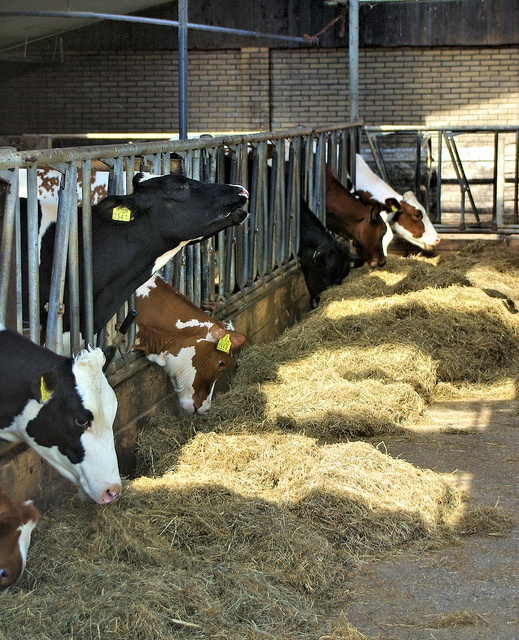Describe the objects in this image and their specific colors. I can see cow in black, darkgray, and gray tones, cow in black, lightgray, darkgray, and gray tones, cow in black, maroon, and darkgray tones, cow in black, maroon, and gray tones, and cow in black, darkgreen, and gray tones in this image. 